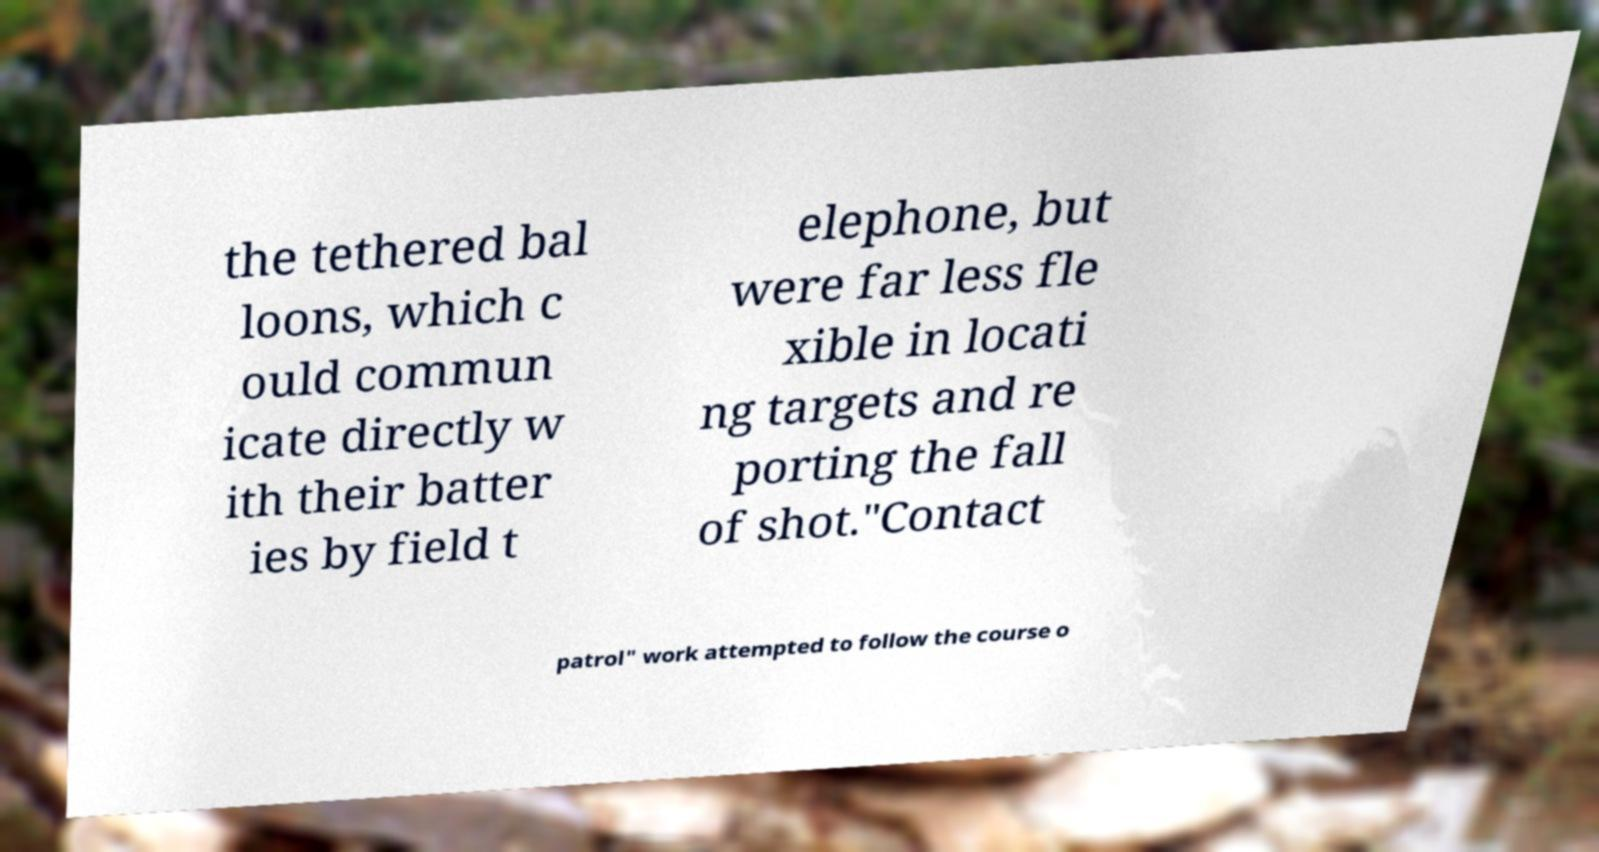Please read and relay the text visible in this image. What does it say? the tethered bal loons, which c ould commun icate directly w ith their batter ies by field t elephone, but were far less fle xible in locati ng targets and re porting the fall of shot."Contact patrol" work attempted to follow the course o 